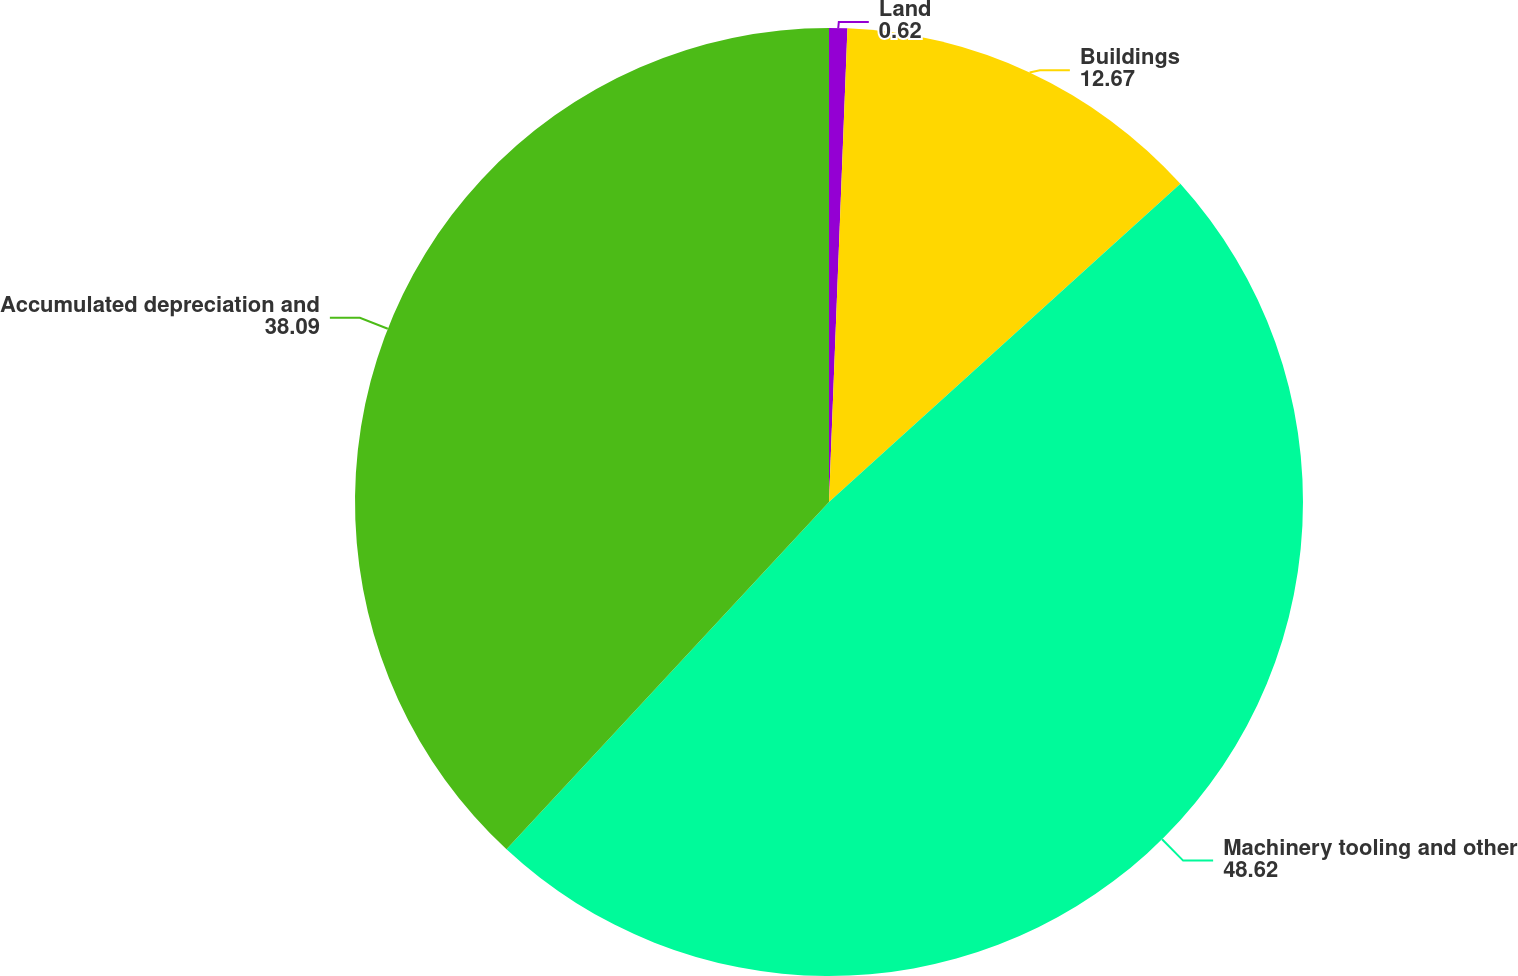<chart> <loc_0><loc_0><loc_500><loc_500><pie_chart><fcel>Land<fcel>Buildings<fcel>Machinery tooling and other<fcel>Accumulated depreciation and<nl><fcel>0.62%<fcel>12.67%<fcel>48.62%<fcel>38.09%<nl></chart> 